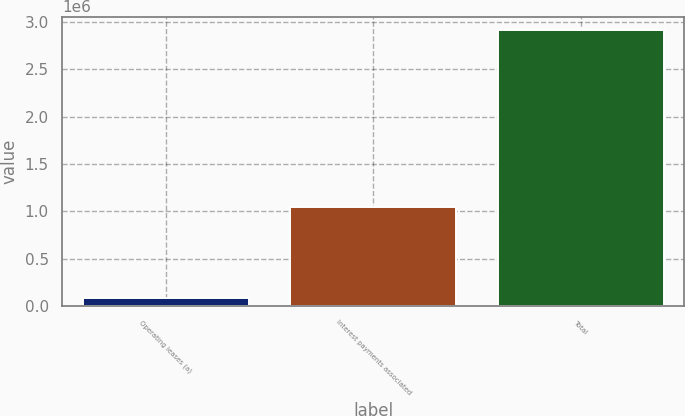Convert chart to OTSL. <chart><loc_0><loc_0><loc_500><loc_500><bar_chart><fcel>Operating leases (a)<fcel>Interest payments associated<fcel>Total<nl><fcel>82625<fcel>1.04095e+06<fcel>2.91284e+06<nl></chart> 